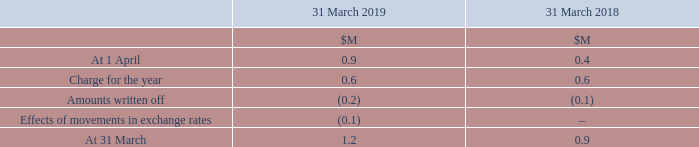The net contract acquisition expense deferred within the Consolidated Statement of Profit or Loss was $0.9M of the total $259.9M of Sales and Marketing costs (2018: $8.4M / $239.9M).
At 31 March 2019, trade receivables at a nominal value of $1.2M (2018: $0.9M) were impaired and fully provided for. Movements in the provision for impairment of receivables were as follows: 31
What was the amount of trade receivables that were impaired and fully provided for in 2019? Nominal value of $1.2m. What was the  Charge for the year for 2019?
Answer scale should be: million. 0.6. For which years were the movements in the provision for impairment of receivables provided? 2019, 2018. In which year was the amount at 31 March larger? 1.2>0.9
Answer: 2019. What was the change in the value at 31 March in 2019 from 2018?
Answer scale should be: million. 1.2-0.9
Answer: 0.3. What was the percentage change in the value at 31 March in 2019 from 2018?
Answer scale should be: percent. (1.2-0.9)/0.9
Answer: 33.33. 